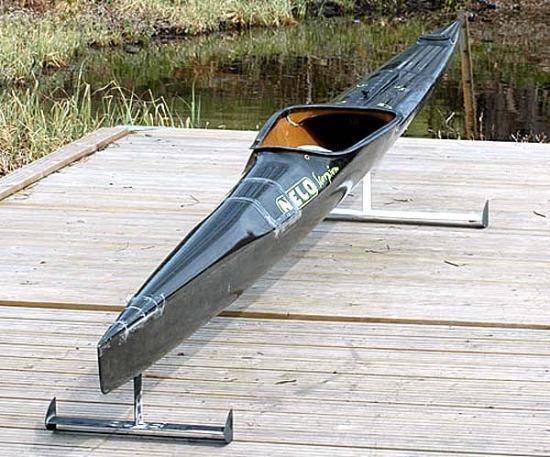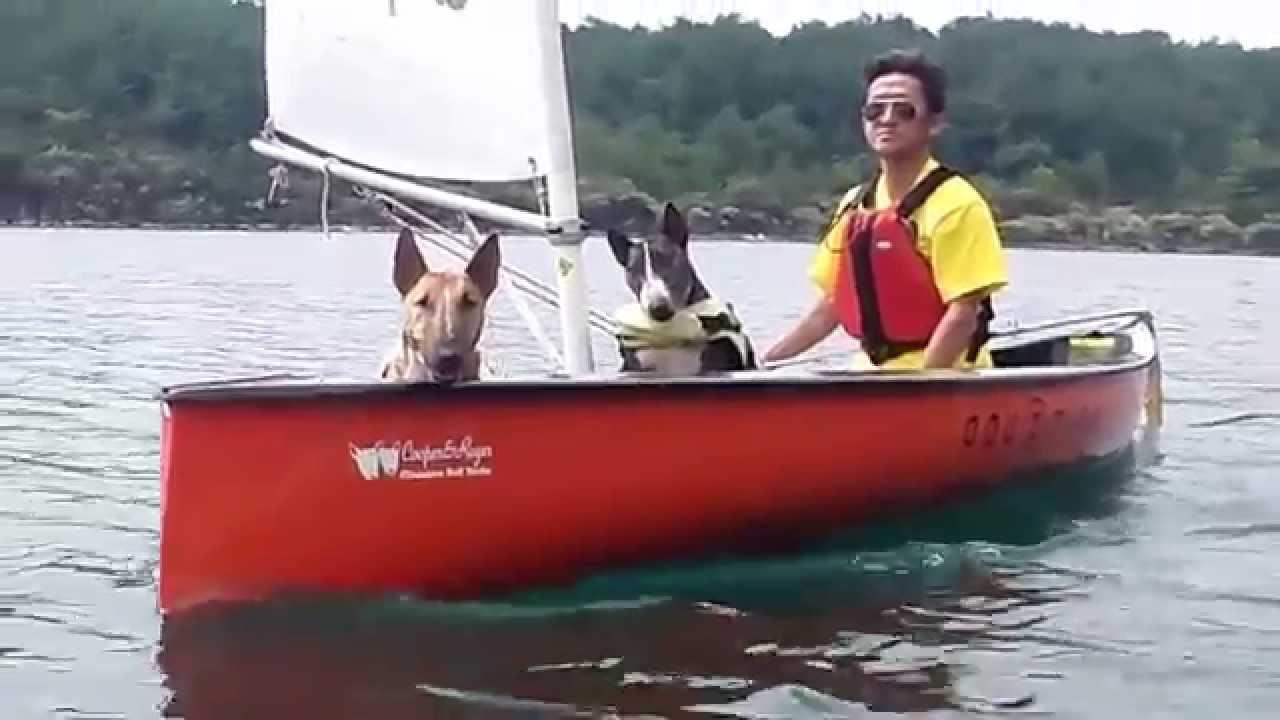The first image is the image on the left, the second image is the image on the right. Considering the images on both sides, is "In one image, there is a white canoe resting slightly on its side on a large rocky area in the middle of a body of water" valid? Answer yes or no. No. The first image is the image on the left, the second image is the image on the right. Assess this claim about the two images: "One image shows a person on a boat in the water, and the other image shows a white canoe pulled up out of the water near gray boulders.". Correct or not? Answer yes or no. No. 